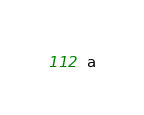<code> <loc_0><loc_0><loc_500><loc_500><_C#_>a</code> 